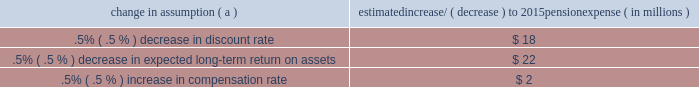The discount rate used to measure pension obligations is determined by comparing the expected future benefits that will be paid under the plan with yields available on high quality corporate bonds of similar duration .
The impact on pension expense of a .5% ( .5 % ) decrease in discount rate in the current environment is an increase of $ 18 million per year .
This sensitivity depends on the economic environment and amount of unrecognized actuarial gains or losses on the measurement date .
The expected long-term return on assets assumption also has a significant effect on pension expense .
The expected return on plan assets is a long-term assumption established by considering historical and anticipated returns of the asset classes invested in by the pension plan and the asset allocation policy currently in place .
For purposes of setting and reviewing this assumption , 201clong term 201d refers to the period over which the plan 2019s projected benefit obligations will be disbursed .
We review this assumption at each measurement date and adjust it if warranted .
Our selection process references certain historical data and the current environment , but primarily utilizes qualitative judgment regarding future return expectations .
To evaluate the continued reasonableness of our assumption , we examine a variety of viewpoints and data .
Various studies have shown that portfolios comprised primarily of u.s .
Equity securities have historically returned approximately 9% ( 9 % ) annually over long periods of time , while u.s .
Debt securities have returned approximately 6% ( 6 % ) annually over long periods .
Application of these historical returns to the plan 2019s allocation ranges for equities and bonds produces a result between 6.50% ( 6.50 % ) and 7.25% ( 7.25 % ) and is one point of reference , among many other factors , that is taken into consideration .
We also examine the plan 2019s actual historical returns over various periods and consider the current economic environment .
Recent experience is considered in our evaluation with appropriate consideration that , especially for short time periods , recent returns are not reliable indicators of future returns .
While annual returns can vary significantly ( actual returns for 2014 , 2013 and 2012 were +6.50% ( +6.50 % ) , +15.48% ( +15.48 % ) , and +15.29% ( +15.29 % ) , respectively ) , the selected assumption represents our estimated long-term average prospective returns .
Acknowledging the potentially wide range for this assumption , we also annually examine the assumption used by other companies with similar pension investment strategies , so that we can ascertain whether our determinations markedly differ from others .
In all cases , however , this data simply informs our process , which places the greatest emphasis on our qualitative judgment of future investment returns , given the conditions existing at each annual measurement date .
Taking into consideration all of these factors , the expected long-term return on plan assets for determining net periodic pension cost for 2014 was 7.00% ( 7.00 % ) , down from 7.50% ( 7.50 % ) for 2013 .
After considering the views of both internal and external capital market advisors , particularly with regard to the effects of the recent economic environment on long-term prospective fixed income returns , we are reducing our expected long-term return on assets to 6.75% ( 6.75 % ) for determining pension cost for under current accounting rules , the difference between expected long-term returns and actual returns is accumulated and amortized to pension expense over future periods .
Each one percentage point difference in actual return compared with our expected return can cause expense in subsequent years to increase or decrease by up to $ 9 million as the impact is amortized into results of operations .
We currently estimate pretax pension expense of $ 9 million in 2015 compared with pretax income of $ 7 million in 2014 .
This year-over-year expected increase in expense reflects the effects of the lower expected return on asset assumption , improved mortality , and the lower discount rate required to be used in 2015 .
These factors will be partially offset by the favorable impact of the increase in plan assets at december 31 , 2014 and the assumed return on a $ 200 million voluntary contribution to the plan made in february 2015 .
The table below reflects the estimated effects on pension expense of certain changes in annual assumptions , using 2015 estimated expense as a baseline .
Table 26 : pension expense 2013 sensitivity analysis change in assumption ( a ) estimated increase/ ( decrease ) to 2015 pension expense ( in millions ) .
( a ) the impact is the effect of changing the specified assumption while holding all other assumptions constant .
Our pension plan contribution requirements are not particularly sensitive to actuarial assumptions .
Investment performance has the most impact on contribution requirements and will drive the amount of required contributions in future years .
Also , current law , including the provisions of the pension protection act of 2006 , sets limits as to both minimum and maximum contributions to the plan .
Notwithstanding the voluntary contribution made in february 2015 noted above , we do not expect to be required to make any contributions to the plan during 2015 .
We maintain other defined benefit plans that have a less significant effect on financial results , including various nonqualified supplemental retirement plans for certain employees , which are described more fully in note 13 employee benefit plans in the notes to consolidated financial statements in item 8 of this report .
66 the pnc financial services group , inc .
2013 form 10-k .
For pension expense , does a .5% ( .5 % ) decrease in discount rate have a greater impact than a .5% ( .5 % ) decrease in expected long-term return on assets? 
Computations: (18 > 22)
Answer: no. 